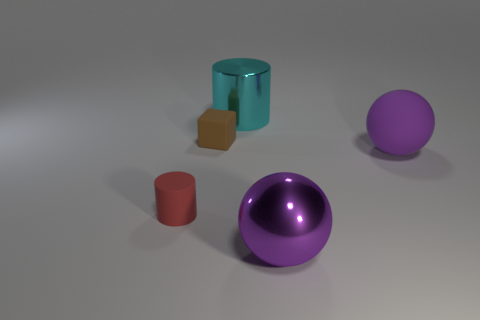Do the object behind the tiny brown matte thing and the large metal object in front of the large matte sphere have the same color?
Your answer should be very brief. No. What size is the metal object that is the same color as the large matte object?
Ensure brevity in your answer.  Large. What number of other objects are there of the same size as the rubber cube?
Your answer should be very brief. 1. The big thing in front of the large purple rubber sphere is what color?
Give a very brief answer. Purple. Do the cylinder in front of the cyan metal thing and the big cyan cylinder have the same material?
Provide a short and direct response. No. What number of things are on the left side of the cyan metal thing and in front of the tiny block?
Make the answer very short. 1. What color is the sphere that is on the left side of the purple thing right of the sphere that is to the left of the matte ball?
Give a very brief answer. Purple. What number of other things are the same shape as the large cyan shiny object?
Make the answer very short. 1. Is there a large ball that is behind the big metal thing that is on the right side of the large cyan cylinder?
Keep it short and to the point. Yes. How many metal things are either red objects or purple balls?
Give a very brief answer. 1. 